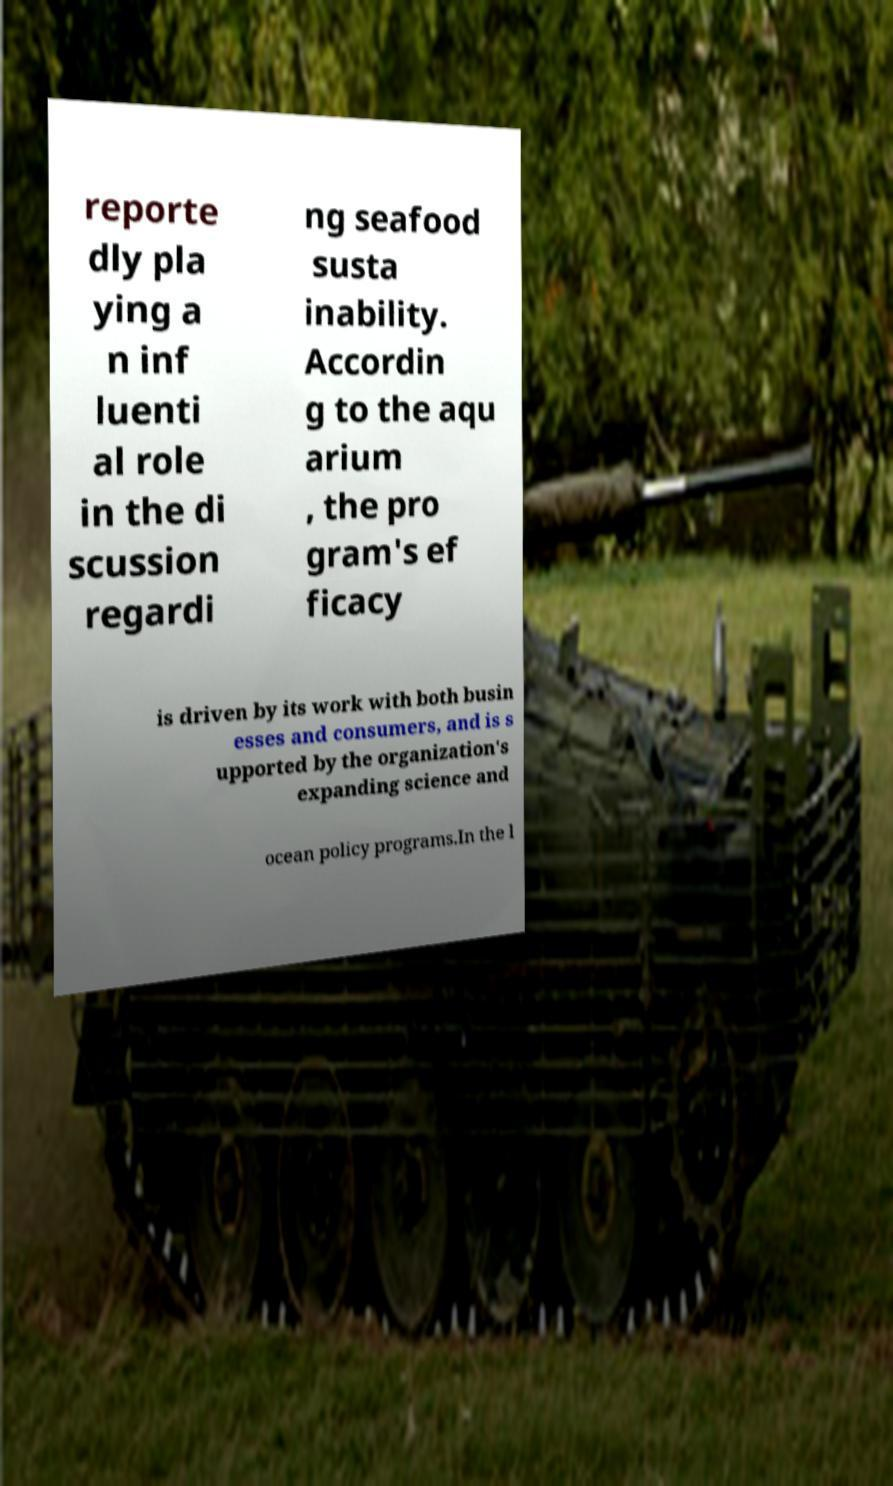I need the written content from this picture converted into text. Can you do that? reporte dly pla ying a n inf luenti al role in the di scussion regardi ng seafood susta inability. Accordin g to the aqu arium , the pro gram's ef ficacy is driven by its work with both busin esses and consumers, and is s upported by the organization's expanding science and ocean policy programs.In the l 